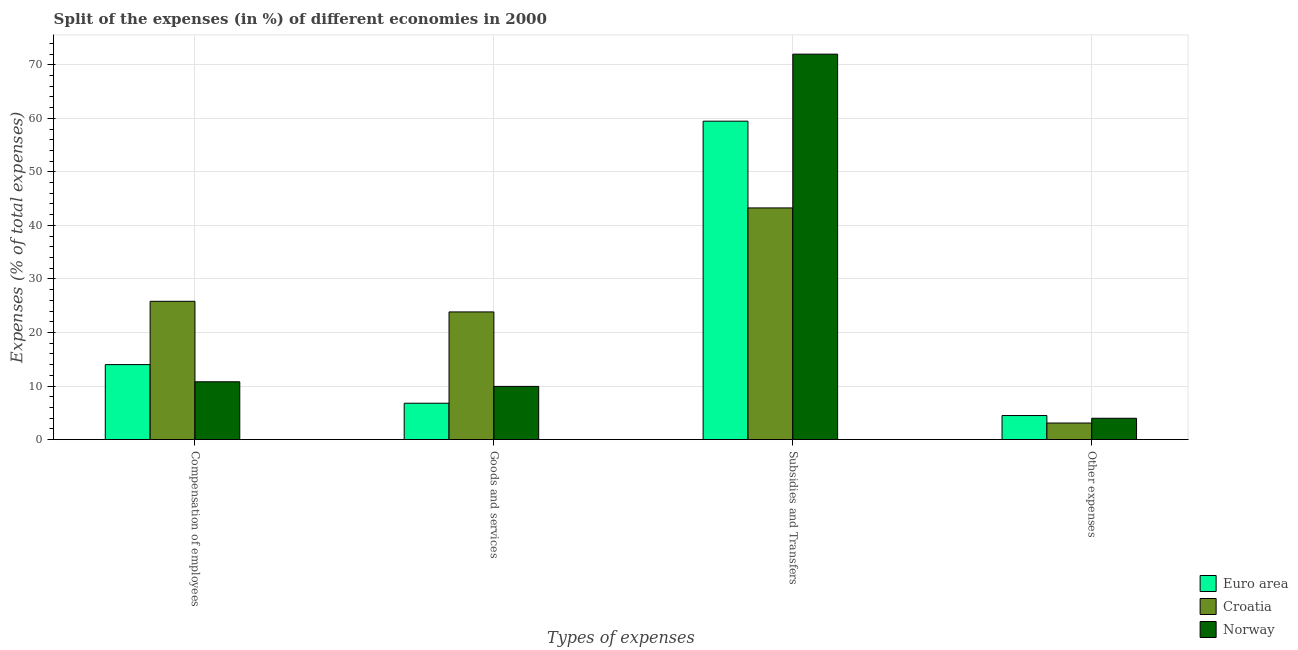How many different coloured bars are there?
Your answer should be compact. 3. Are the number of bars per tick equal to the number of legend labels?
Provide a short and direct response. Yes. How many bars are there on the 1st tick from the left?
Ensure brevity in your answer.  3. How many bars are there on the 2nd tick from the right?
Keep it short and to the point. 3. What is the label of the 1st group of bars from the left?
Provide a short and direct response. Compensation of employees. What is the percentage of amount spent on subsidies in Euro area?
Your response must be concise. 59.47. Across all countries, what is the maximum percentage of amount spent on subsidies?
Make the answer very short. 71.99. Across all countries, what is the minimum percentage of amount spent on compensation of employees?
Your answer should be compact. 10.8. In which country was the percentage of amount spent on compensation of employees maximum?
Give a very brief answer. Croatia. In which country was the percentage of amount spent on other expenses minimum?
Your answer should be compact. Croatia. What is the total percentage of amount spent on compensation of employees in the graph?
Give a very brief answer. 50.64. What is the difference between the percentage of amount spent on subsidies in Euro area and that in Croatia?
Provide a succinct answer. 16.2. What is the difference between the percentage of amount spent on other expenses in Norway and the percentage of amount spent on compensation of employees in Croatia?
Ensure brevity in your answer.  -21.84. What is the average percentage of amount spent on compensation of employees per country?
Your answer should be very brief. 16.88. What is the difference between the percentage of amount spent on goods and services and percentage of amount spent on subsidies in Croatia?
Keep it short and to the point. -19.42. In how many countries, is the percentage of amount spent on compensation of employees greater than 70 %?
Offer a terse response. 0. What is the ratio of the percentage of amount spent on goods and services in Norway to that in Croatia?
Offer a terse response. 0.42. What is the difference between the highest and the second highest percentage of amount spent on subsidies?
Your response must be concise. 12.52. What is the difference between the highest and the lowest percentage of amount spent on subsidies?
Ensure brevity in your answer.  28.72. In how many countries, is the percentage of amount spent on compensation of employees greater than the average percentage of amount spent on compensation of employees taken over all countries?
Keep it short and to the point. 1. Is it the case that in every country, the sum of the percentage of amount spent on other expenses and percentage of amount spent on subsidies is greater than the sum of percentage of amount spent on goods and services and percentage of amount spent on compensation of employees?
Your answer should be compact. No. What does the 2nd bar from the left in Goods and services represents?
Give a very brief answer. Croatia. What does the 3rd bar from the right in Goods and services represents?
Your answer should be compact. Euro area. Is it the case that in every country, the sum of the percentage of amount spent on compensation of employees and percentage of amount spent on goods and services is greater than the percentage of amount spent on subsidies?
Ensure brevity in your answer.  No. Where does the legend appear in the graph?
Keep it short and to the point. Bottom right. What is the title of the graph?
Your answer should be compact. Split of the expenses (in %) of different economies in 2000. Does "Guinea-Bissau" appear as one of the legend labels in the graph?
Ensure brevity in your answer.  No. What is the label or title of the X-axis?
Give a very brief answer. Types of expenses. What is the label or title of the Y-axis?
Provide a short and direct response. Expenses (% of total expenses). What is the Expenses (% of total expenses) in Euro area in Compensation of employees?
Your answer should be very brief. 14.01. What is the Expenses (% of total expenses) of Croatia in Compensation of employees?
Your answer should be very brief. 25.83. What is the Expenses (% of total expenses) in Norway in Compensation of employees?
Your answer should be compact. 10.8. What is the Expenses (% of total expenses) in Euro area in Goods and services?
Keep it short and to the point. 6.79. What is the Expenses (% of total expenses) in Croatia in Goods and services?
Make the answer very short. 23.84. What is the Expenses (% of total expenses) in Norway in Goods and services?
Offer a very short reply. 9.94. What is the Expenses (% of total expenses) in Euro area in Subsidies and Transfers?
Give a very brief answer. 59.47. What is the Expenses (% of total expenses) of Croatia in Subsidies and Transfers?
Your response must be concise. 43.27. What is the Expenses (% of total expenses) in Norway in Subsidies and Transfers?
Your answer should be very brief. 71.99. What is the Expenses (% of total expenses) of Euro area in Other expenses?
Offer a very short reply. 4.49. What is the Expenses (% of total expenses) in Croatia in Other expenses?
Your response must be concise. 3.1. What is the Expenses (% of total expenses) of Norway in Other expenses?
Provide a short and direct response. 3.99. Across all Types of expenses, what is the maximum Expenses (% of total expenses) in Euro area?
Ensure brevity in your answer.  59.47. Across all Types of expenses, what is the maximum Expenses (% of total expenses) of Croatia?
Your answer should be compact. 43.27. Across all Types of expenses, what is the maximum Expenses (% of total expenses) of Norway?
Provide a succinct answer. 71.99. Across all Types of expenses, what is the minimum Expenses (% of total expenses) in Euro area?
Offer a terse response. 4.49. Across all Types of expenses, what is the minimum Expenses (% of total expenses) of Croatia?
Provide a short and direct response. 3.1. Across all Types of expenses, what is the minimum Expenses (% of total expenses) in Norway?
Your response must be concise. 3.99. What is the total Expenses (% of total expenses) of Euro area in the graph?
Provide a succinct answer. 84.76. What is the total Expenses (% of total expenses) of Croatia in the graph?
Make the answer very short. 96.04. What is the total Expenses (% of total expenses) in Norway in the graph?
Provide a short and direct response. 96.71. What is the difference between the Expenses (% of total expenses) of Euro area in Compensation of employees and that in Goods and services?
Ensure brevity in your answer.  7.21. What is the difference between the Expenses (% of total expenses) of Croatia in Compensation of employees and that in Goods and services?
Provide a short and direct response. 1.99. What is the difference between the Expenses (% of total expenses) of Norway in Compensation of employees and that in Goods and services?
Provide a succinct answer. 0.86. What is the difference between the Expenses (% of total expenses) of Euro area in Compensation of employees and that in Subsidies and Transfers?
Keep it short and to the point. -45.46. What is the difference between the Expenses (% of total expenses) of Croatia in Compensation of employees and that in Subsidies and Transfers?
Provide a short and direct response. -17.44. What is the difference between the Expenses (% of total expenses) of Norway in Compensation of employees and that in Subsidies and Transfers?
Provide a succinct answer. -61.19. What is the difference between the Expenses (% of total expenses) of Euro area in Compensation of employees and that in Other expenses?
Make the answer very short. 9.51. What is the difference between the Expenses (% of total expenses) of Croatia in Compensation of employees and that in Other expenses?
Ensure brevity in your answer.  22.73. What is the difference between the Expenses (% of total expenses) in Norway in Compensation of employees and that in Other expenses?
Offer a very short reply. 6.81. What is the difference between the Expenses (% of total expenses) of Euro area in Goods and services and that in Subsidies and Transfers?
Give a very brief answer. -52.67. What is the difference between the Expenses (% of total expenses) in Croatia in Goods and services and that in Subsidies and Transfers?
Provide a succinct answer. -19.42. What is the difference between the Expenses (% of total expenses) in Norway in Goods and services and that in Subsidies and Transfers?
Keep it short and to the point. -62.05. What is the difference between the Expenses (% of total expenses) of Euro area in Goods and services and that in Other expenses?
Provide a succinct answer. 2.3. What is the difference between the Expenses (% of total expenses) of Croatia in Goods and services and that in Other expenses?
Your answer should be very brief. 20.75. What is the difference between the Expenses (% of total expenses) of Norway in Goods and services and that in Other expenses?
Give a very brief answer. 5.95. What is the difference between the Expenses (% of total expenses) of Euro area in Subsidies and Transfers and that in Other expenses?
Offer a very short reply. 54.97. What is the difference between the Expenses (% of total expenses) of Croatia in Subsidies and Transfers and that in Other expenses?
Your answer should be compact. 40.17. What is the difference between the Expenses (% of total expenses) in Norway in Subsidies and Transfers and that in Other expenses?
Provide a succinct answer. 68. What is the difference between the Expenses (% of total expenses) of Euro area in Compensation of employees and the Expenses (% of total expenses) of Croatia in Goods and services?
Your answer should be compact. -9.83. What is the difference between the Expenses (% of total expenses) of Euro area in Compensation of employees and the Expenses (% of total expenses) of Norway in Goods and services?
Make the answer very short. 4.07. What is the difference between the Expenses (% of total expenses) of Croatia in Compensation of employees and the Expenses (% of total expenses) of Norway in Goods and services?
Make the answer very short. 15.89. What is the difference between the Expenses (% of total expenses) of Euro area in Compensation of employees and the Expenses (% of total expenses) of Croatia in Subsidies and Transfers?
Keep it short and to the point. -29.26. What is the difference between the Expenses (% of total expenses) in Euro area in Compensation of employees and the Expenses (% of total expenses) in Norway in Subsidies and Transfers?
Your answer should be very brief. -57.98. What is the difference between the Expenses (% of total expenses) of Croatia in Compensation of employees and the Expenses (% of total expenses) of Norway in Subsidies and Transfers?
Provide a succinct answer. -46.16. What is the difference between the Expenses (% of total expenses) in Euro area in Compensation of employees and the Expenses (% of total expenses) in Croatia in Other expenses?
Your answer should be compact. 10.91. What is the difference between the Expenses (% of total expenses) of Euro area in Compensation of employees and the Expenses (% of total expenses) of Norway in Other expenses?
Your answer should be very brief. 10.02. What is the difference between the Expenses (% of total expenses) of Croatia in Compensation of employees and the Expenses (% of total expenses) of Norway in Other expenses?
Your answer should be compact. 21.84. What is the difference between the Expenses (% of total expenses) of Euro area in Goods and services and the Expenses (% of total expenses) of Croatia in Subsidies and Transfers?
Your answer should be very brief. -36.47. What is the difference between the Expenses (% of total expenses) in Euro area in Goods and services and the Expenses (% of total expenses) in Norway in Subsidies and Transfers?
Make the answer very short. -65.19. What is the difference between the Expenses (% of total expenses) in Croatia in Goods and services and the Expenses (% of total expenses) in Norway in Subsidies and Transfers?
Make the answer very short. -48.14. What is the difference between the Expenses (% of total expenses) in Euro area in Goods and services and the Expenses (% of total expenses) in Croatia in Other expenses?
Offer a terse response. 3.7. What is the difference between the Expenses (% of total expenses) of Euro area in Goods and services and the Expenses (% of total expenses) of Norway in Other expenses?
Your answer should be compact. 2.81. What is the difference between the Expenses (% of total expenses) in Croatia in Goods and services and the Expenses (% of total expenses) in Norway in Other expenses?
Offer a very short reply. 19.86. What is the difference between the Expenses (% of total expenses) in Euro area in Subsidies and Transfers and the Expenses (% of total expenses) in Croatia in Other expenses?
Your response must be concise. 56.37. What is the difference between the Expenses (% of total expenses) in Euro area in Subsidies and Transfers and the Expenses (% of total expenses) in Norway in Other expenses?
Offer a terse response. 55.48. What is the difference between the Expenses (% of total expenses) in Croatia in Subsidies and Transfers and the Expenses (% of total expenses) in Norway in Other expenses?
Give a very brief answer. 39.28. What is the average Expenses (% of total expenses) in Euro area per Types of expenses?
Offer a terse response. 21.19. What is the average Expenses (% of total expenses) of Croatia per Types of expenses?
Give a very brief answer. 24.01. What is the average Expenses (% of total expenses) in Norway per Types of expenses?
Your answer should be very brief. 24.18. What is the difference between the Expenses (% of total expenses) in Euro area and Expenses (% of total expenses) in Croatia in Compensation of employees?
Keep it short and to the point. -11.82. What is the difference between the Expenses (% of total expenses) of Euro area and Expenses (% of total expenses) of Norway in Compensation of employees?
Make the answer very short. 3.21. What is the difference between the Expenses (% of total expenses) of Croatia and Expenses (% of total expenses) of Norway in Compensation of employees?
Keep it short and to the point. 15.03. What is the difference between the Expenses (% of total expenses) in Euro area and Expenses (% of total expenses) in Croatia in Goods and services?
Make the answer very short. -17.05. What is the difference between the Expenses (% of total expenses) in Euro area and Expenses (% of total expenses) in Norway in Goods and services?
Make the answer very short. -3.14. What is the difference between the Expenses (% of total expenses) of Croatia and Expenses (% of total expenses) of Norway in Goods and services?
Your response must be concise. 13.91. What is the difference between the Expenses (% of total expenses) of Euro area and Expenses (% of total expenses) of Croatia in Subsidies and Transfers?
Your answer should be compact. 16.2. What is the difference between the Expenses (% of total expenses) in Euro area and Expenses (% of total expenses) in Norway in Subsidies and Transfers?
Your response must be concise. -12.52. What is the difference between the Expenses (% of total expenses) in Croatia and Expenses (% of total expenses) in Norway in Subsidies and Transfers?
Your response must be concise. -28.72. What is the difference between the Expenses (% of total expenses) in Euro area and Expenses (% of total expenses) in Croatia in Other expenses?
Ensure brevity in your answer.  1.4. What is the difference between the Expenses (% of total expenses) in Euro area and Expenses (% of total expenses) in Norway in Other expenses?
Provide a short and direct response. 0.51. What is the difference between the Expenses (% of total expenses) in Croatia and Expenses (% of total expenses) in Norway in Other expenses?
Provide a short and direct response. -0.89. What is the ratio of the Expenses (% of total expenses) in Euro area in Compensation of employees to that in Goods and services?
Give a very brief answer. 2.06. What is the ratio of the Expenses (% of total expenses) of Norway in Compensation of employees to that in Goods and services?
Your response must be concise. 1.09. What is the ratio of the Expenses (% of total expenses) in Euro area in Compensation of employees to that in Subsidies and Transfers?
Offer a very short reply. 0.24. What is the ratio of the Expenses (% of total expenses) of Croatia in Compensation of employees to that in Subsidies and Transfers?
Ensure brevity in your answer.  0.6. What is the ratio of the Expenses (% of total expenses) in Euro area in Compensation of employees to that in Other expenses?
Offer a very short reply. 3.12. What is the ratio of the Expenses (% of total expenses) of Croatia in Compensation of employees to that in Other expenses?
Provide a succinct answer. 8.34. What is the ratio of the Expenses (% of total expenses) in Norway in Compensation of employees to that in Other expenses?
Your response must be concise. 2.71. What is the ratio of the Expenses (% of total expenses) in Euro area in Goods and services to that in Subsidies and Transfers?
Make the answer very short. 0.11. What is the ratio of the Expenses (% of total expenses) of Croatia in Goods and services to that in Subsidies and Transfers?
Provide a short and direct response. 0.55. What is the ratio of the Expenses (% of total expenses) of Norway in Goods and services to that in Subsidies and Transfers?
Ensure brevity in your answer.  0.14. What is the ratio of the Expenses (% of total expenses) in Euro area in Goods and services to that in Other expenses?
Keep it short and to the point. 1.51. What is the ratio of the Expenses (% of total expenses) in Croatia in Goods and services to that in Other expenses?
Your answer should be very brief. 7.7. What is the ratio of the Expenses (% of total expenses) of Norway in Goods and services to that in Other expenses?
Offer a very short reply. 2.49. What is the ratio of the Expenses (% of total expenses) of Euro area in Subsidies and Transfers to that in Other expenses?
Offer a terse response. 13.23. What is the ratio of the Expenses (% of total expenses) of Croatia in Subsidies and Transfers to that in Other expenses?
Provide a succinct answer. 13.97. What is the ratio of the Expenses (% of total expenses) of Norway in Subsidies and Transfers to that in Other expenses?
Your response must be concise. 18.06. What is the difference between the highest and the second highest Expenses (% of total expenses) of Euro area?
Offer a terse response. 45.46. What is the difference between the highest and the second highest Expenses (% of total expenses) of Croatia?
Keep it short and to the point. 17.44. What is the difference between the highest and the second highest Expenses (% of total expenses) of Norway?
Your answer should be very brief. 61.19. What is the difference between the highest and the lowest Expenses (% of total expenses) of Euro area?
Offer a terse response. 54.97. What is the difference between the highest and the lowest Expenses (% of total expenses) of Croatia?
Provide a succinct answer. 40.17. What is the difference between the highest and the lowest Expenses (% of total expenses) of Norway?
Provide a short and direct response. 68. 